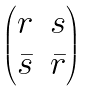Convert formula to latex. <formula><loc_0><loc_0><loc_500><loc_500>\begin{pmatrix} r & s \\ \bar { s } & \bar { r } \end{pmatrix}</formula> 